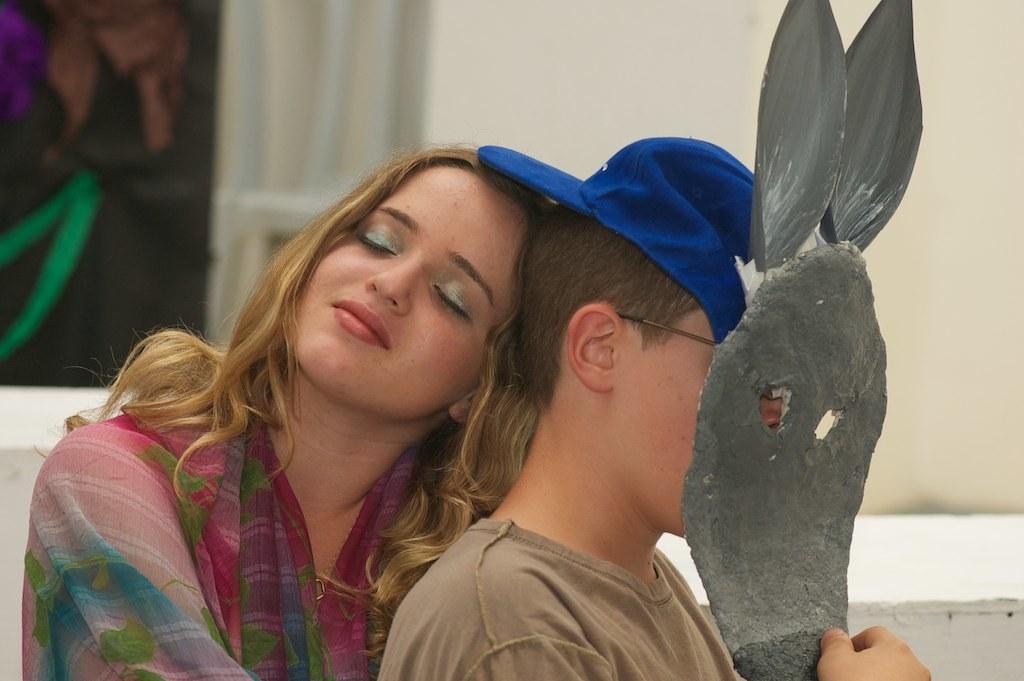How would you summarize this image in a sentence or two? In this image we can see a boy holding a mask and he is wearing a blue color cap. There is a lady. In the background of the image there is wall. 